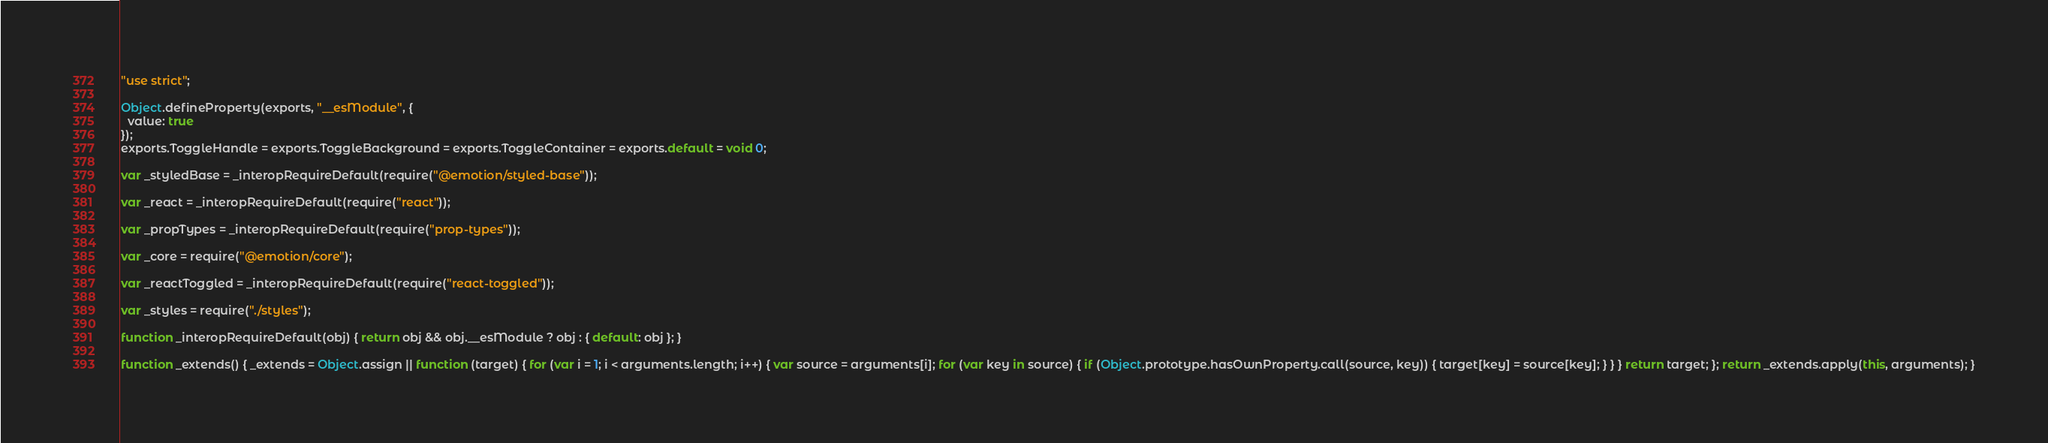<code> <loc_0><loc_0><loc_500><loc_500><_JavaScript_>"use strict";

Object.defineProperty(exports, "__esModule", {
  value: true
});
exports.ToggleHandle = exports.ToggleBackground = exports.ToggleContainer = exports.default = void 0;

var _styledBase = _interopRequireDefault(require("@emotion/styled-base"));

var _react = _interopRequireDefault(require("react"));

var _propTypes = _interopRequireDefault(require("prop-types"));

var _core = require("@emotion/core");

var _reactToggled = _interopRequireDefault(require("react-toggled"));

var _styles = require("./styles");

function _interopRequireDefault(obj) { return obj && obj.__esModule ? obj : { default: obj }; }

function _extends() { _extends = Object.assign || function (target) { for (var i = 1; i < arguments.length; i++) { var source = arguments[i]; for (var key in source) { if (Object.prototype.hasOwnProperty.call(source, key)) { target[key] = source[key]; } } } return target; }; return _extends.apply(this, arguments); }
</code> 